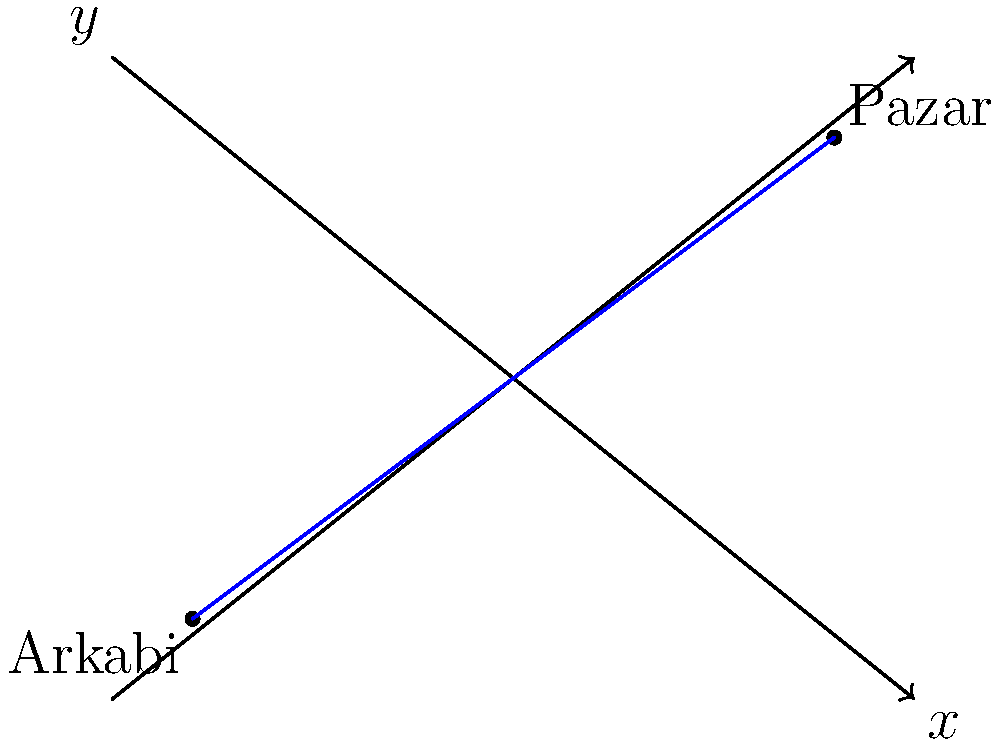Two historic Laz villages, Arkabi and Pazar, are plotted on a 2D coordinate system representing a map of the Black Sea coast. Arkabi is located at the origin (0,0), while Pazar is situated at the point (8,6). Calculate the straight-line distance between these two villages. To find the distance between two points on a 2D plane, we can use the distance formula derived from the Pythagorean theorem:

$$ d = \sqrt{(x_2 - x_1)^2 + (y_2 - y_1)^2} $$

Where $(x_1, y_1)$ represents the coordinates of the first point (Arkabi) and $(x_2, y_2)$ represents the coordinates of the second point (Pazar).

Given:
- Arkabi: $(x_1, y_1) = (0, 0)$
- Pazar: $(x_2, y_2) = (8, 6)$

Let's substitute these values into the formula:

$$ d = \sqrt{(8 - 0)^2 + (6 - 0)^2} $$

Simplify:
$$ d = \sqrt{8^2 + 6^2} $$

Calculate the squares:
$$ d = \sqrt{64 + 36} $$

Sum under the square root:
$$ d = \sqrt{100} $$

Simplify:
$$ d = 10 $$

Therefore, the straight-line distance between Arkabi and Pazar is 10 units on the map.
Answer: 10 units 